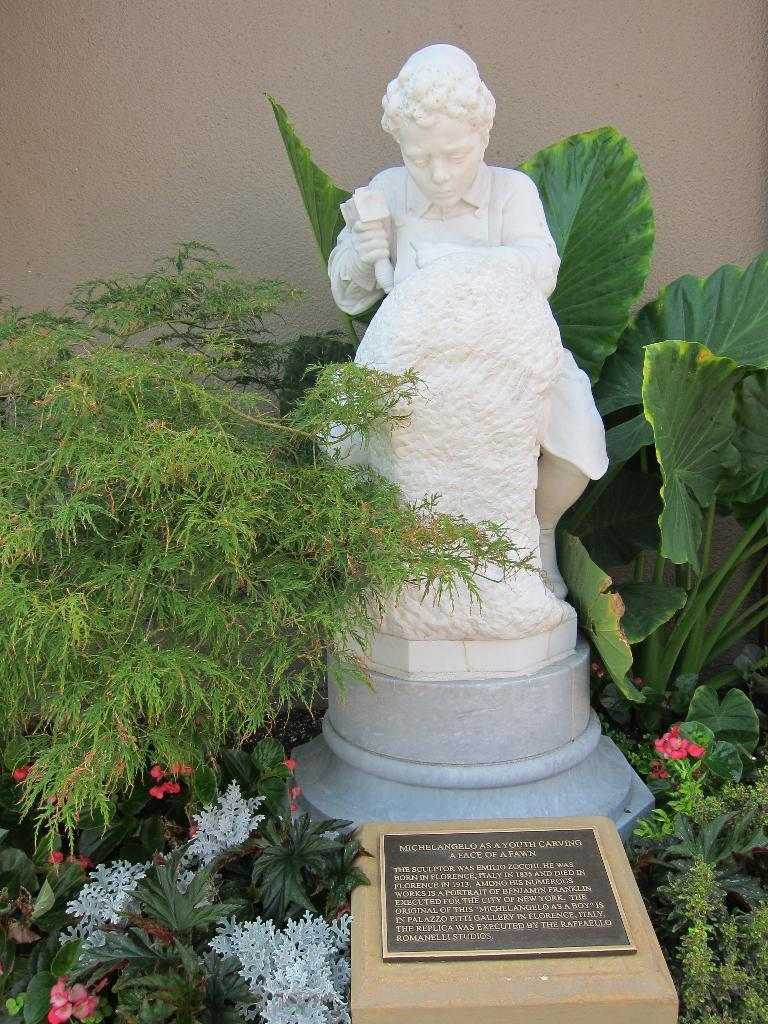What is the main subject of the image? There is a statue of a person in the image. What is located in front of the statue? There is a stone and a headstone in front of the statue. What type of plants can be seen in the image? Flower plants are present in the image. What is visible behind the statue? There is a wall behind the statue. What type of polish is being applied to the statue in the image? There is no indication in the image that any polish is being applied to the statue. Can you tell me where the nearest store is located in the image? There is no store present in the image. 